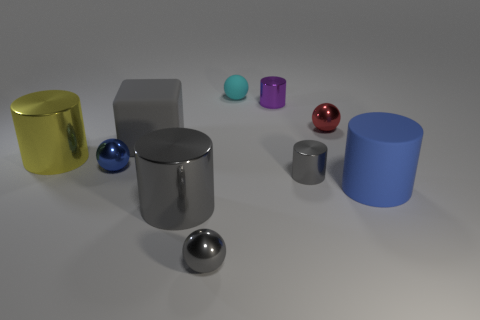What can you infer about the texture of the surfaces of the objects? The surfaces of the metallic objects show reflections and high gloss, indicative of smooth textures. The non-metallic objects have more subdued reflections, suggesting they have a rougher texture. 